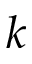Convert formula to latex. <formula><loc_0><loc_0><loc_500><loc_500>k</formula> 